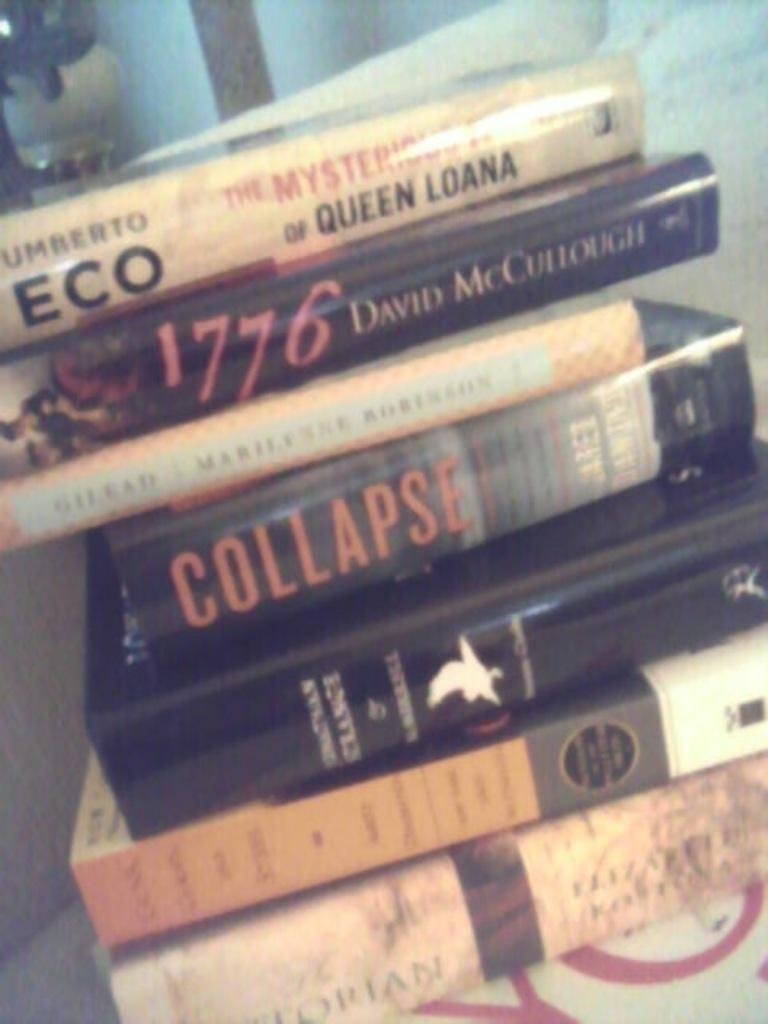Provide a one-sentence caption for the provided image. A stack of books including The Mysterious Flame of Queen Loana by Umberto Eco and 1776 by David McCullough. 